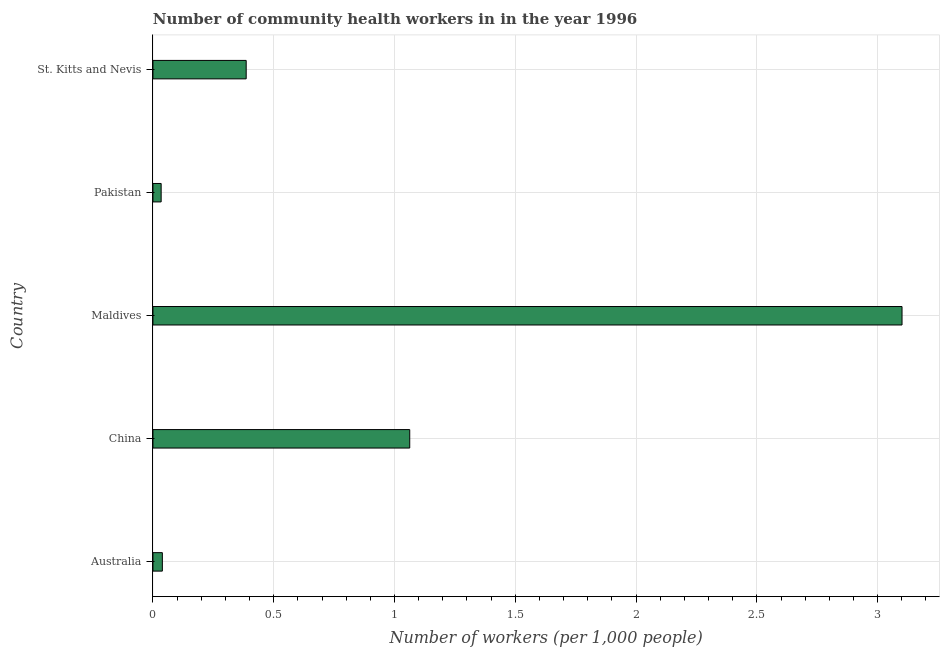Does the graph contain any zero values?
Ensure brevity in your answer.  No. What is the title of the graph?
Provide a succinct answer. Number of community health workers in in the year 1996. What is the label or title of the X-axis?
Your answer should be very brief. Number of workers (per 1,0 people). What is the number of community health workers in Pakistan?
Offer a very short reply. 0.03. Across all countries, what is the maximum number of community health workers?
Your answer should be very brief. 3.1. Across all countries, what is the minimum number of community health workers?
Make the answer very short. 0.03. In which country was the number of community health workers maximum?
Provide a succinct answer. Maldives. What is the sum of the number of community health workers?
Keep it short and to the point. 4.62. What is the difference between the number of community health workers in China and Maldives?
Your answer should be very brief. -2.04. What is the average number of community health workers per country?
Offer a very short reply. 0.93. What is the median number of community health workers?
Offer a very short reply. 0.39. What is the ratio of the number of community health workers in China to that in St. Kitts and Nevis?
Offer a terse response. 2.75. Is the difference between the number of community health workers in Australia and China greater than the difference between any two countries?
Keep it short and to the point. No. What is the difference between the highest and the second highest number of community health workers?
Keep it short and to the point. 2.04. What is the difference between the highest and the lowest number of community health workers?
Provide a succinct answer. 3.07. How many bars are there?
Keep it short and to the point. 5. How many countries are there in the graph?
Give a very brief answer. 5. What is the difference between two consecutive major ticks on the X-axis?
Give a very brief answer. 0.5. Are the values on the major ticks of X-axis written in scientific E-notation?
Provide a short and direct response. No. What is the Number of workers (per 1,000 people) in Australia?
Give a very brief answer. 0.04. What is the Number of workers (per 1,000 people) in China?
Your response must be concise. 1.06. What is the Number of workers (per 1,000 people) of Maldives?
Provide a succinct answer. 3.1. What is the Number of workers (per 1,000 people) in Pakistan?
Offer a very short reply. 0.03. What is the Number of workers (per 1,000 people) of St. Kitts and Nevis?
Provide a succinct answer. 0.39. What is the difference between the Number of workers (per 1,000 people) in Australia and China?
Provide a short and direct response. -1.02. What is the difference between the Number of workers (per 1,000 people) in Australia and Maldives?
Provide a succinct answer. -3.06. What is the difference between the Number of workers (per 1,000 people) in Australia and Pakistan?
Your answer should be compact. 0.01. What is the difference between the Number of workers (per 1,000 people) in Australia and St. Kitts and Nevis?
Your response must be concise. -0.35. What is the difference between the Number of workers (per 1,000 people) in China and Maldives?
Your answer should be compact. -2.04. What is the difference between the Number of workers (per 1,000 people) in China and Pakistan?
Your response must be concise. 1.03. What is the difference between the Number of workers (per 1,000 people) in China and St. Kitts and Nevis?
Offer a terse response. 0.68. What is the difference between the Number of workers (per 1,000 people) in Maldives and Pakistan?
Ensure brevity in your answer.  3.07. What is the difference between the Number of workers (per 1,000 people) in Maldives and St. Kitts and Nevis?
Ensure brevity in your answer.  2.71. What is the difference between the Number of workers (per 1,000 people) in Pakistan and St. Kitts and Nevis?
Give a very brief answer. -0.35. What is the ratio of the Number of workers (per 1,000 people) in Australia to that in China?
Your answer should be very brief. 0.04. What is the ratio of the Number of workers (per 1,000 people) in Australia to that in Maldives?
Your answer should be very brief. 0.01. What is the ratio of the Number of workers (per 1,000 people) in Australia to that in Pakistan?
Your response must be concise. 1.15. What is the ratio of the Number of workers (per 1,000 people) in Australia to that in St. Kitts and Nevis?
Your response must be concise. 0.1. What is the ratio of the Number of workers (per 1,000 people) in China to that in Maldives?
Give a very brief answer. 0.34. What is the ratio of the Number of workers (per 1,000 people) in China to that in Pakistan?
Offer a very short reply. 31.27. What is the ratio of the Number of workers (per 1,000 people) in China to that in St. Kitts and Nevis?
Provide a short and direct response. 2.75. What is the ratio of the Number of workers (per 1,000 people) in Maldives to that in Pakistan?
Offer a very short reply. 91.21. What is the ratio of the Number of workers (per 1,000 people) in Maldives to that in St. Kitts and Nevis?
Your response must be concise. 8.03. What is the ratio of the Number of workers (per 1,000 people) in Pakistan to that in St. Kitts and Nevis?
Your response must be concise. 0.09. 